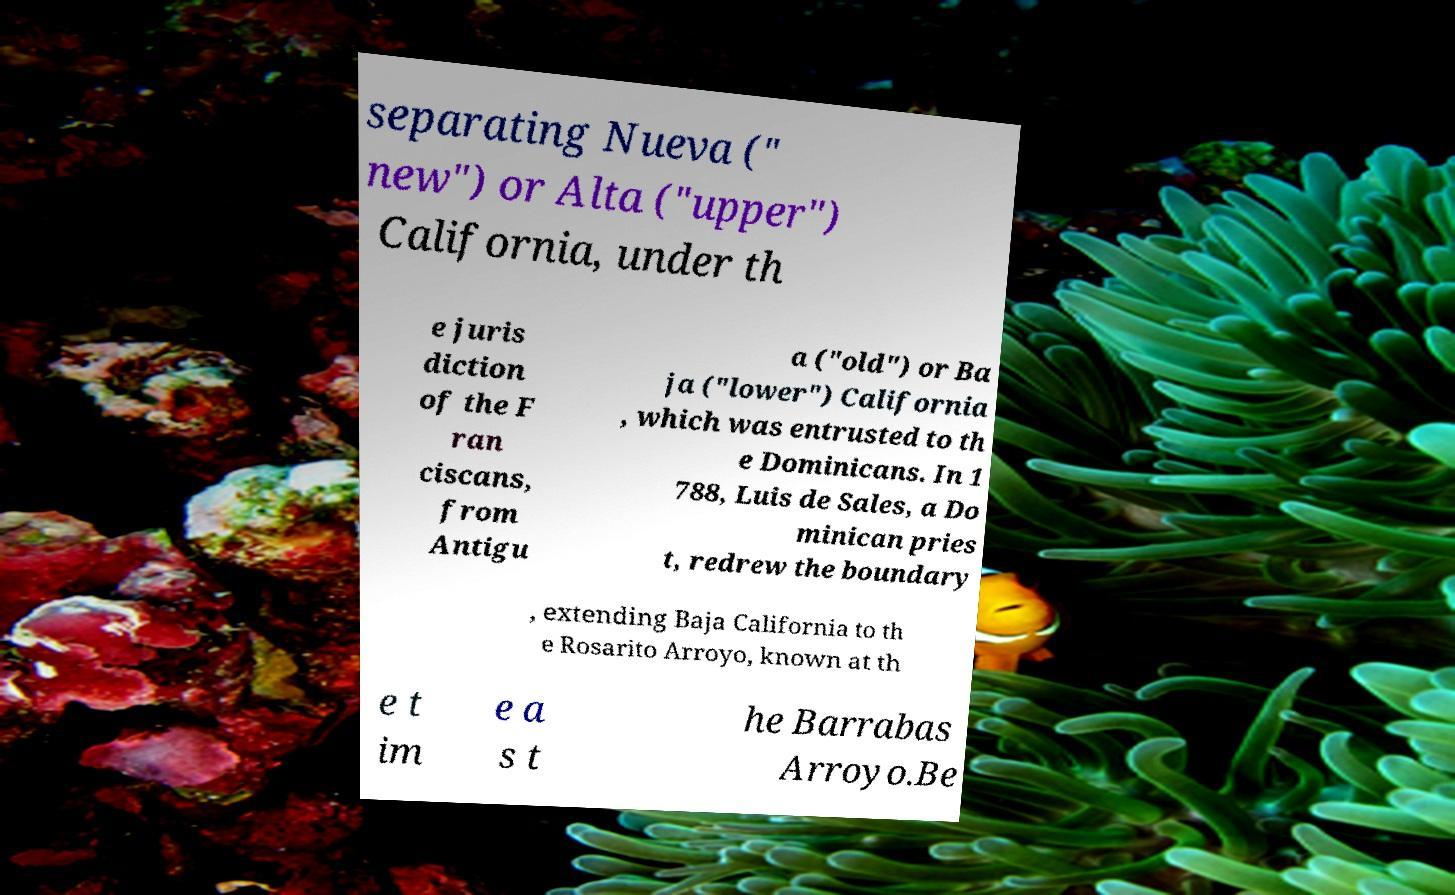I need the written content from this picture converted into text. Can you do that? separating Nueva (" new") or Alta ("upper") California, under th e juris diction of the F ran ciscans, from Antigu a ("old") or Ba ja ("lower") California , which was entrusted to th e Dominicans. In 1 788, Luis de Sales, a Do minican pries t, redrew the boundary , extending Baja California to th e Rosarito Arroyo, known at th e t im e a s t he Barrabas Arroyo.Be 